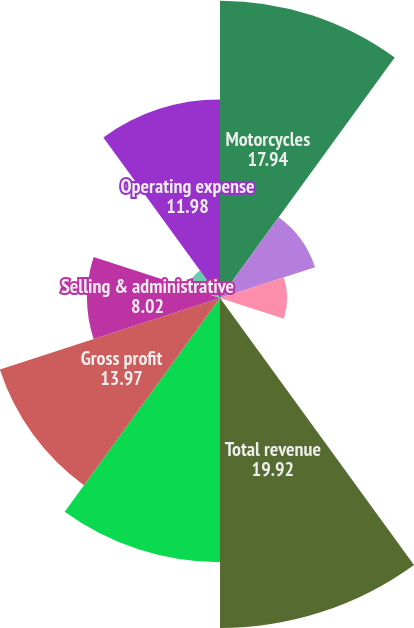Convert chart. <chart><loc_0><loc_0><loc_500><loc_500><pie_chart><fcel>Motorcycles<fcel>Parts & Accessories<fcel>General Merchandise<fcel>Other<fcel>Total revenue<fcel>Cost of goods sold<fcel>Gross profit<fcel>Selling & administrative<fcel>Engineering expense<fcel>Operating expense<nl><fcel>17.94%<fcel>6.03%<fcel>4.05%<fcel>0.08%<fcel>19.92%<fcel>15.95%<fcel>13.97%<fcel>8.02%<fcel>2.06%<fcel>11.98%<nl></chart> 